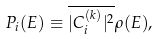<formula> <loc_0><loc_0><loc_500><loc_500>P _ { i } ( E ) \equiv \overline { | C _ { i } ^ { ( k ) } | ^ { 2 } } \rho ( E ) ,</formula> 